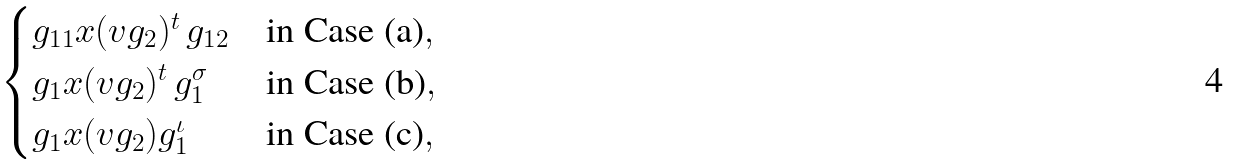<formula> <loc_0><loc_0><loc_500><loc_500>\begin{cases} g _ { 1 1 } x ( v g _ { 2 } ) ^ { t } \, g _ { 1 2 } & \text {in Case (a)} , \\ g _ { 1 } x ( v g _ { 2 } ) ^ { t } \, g _ { 1 } ^ { \sigma } & \text {in Case (b)} , \\ g _ { 1 } x ( v g _ { 2 } ) g _ { 1 } ^ { \iota } & \text {in Case (c)} , \\ \end{cases}</formula> 